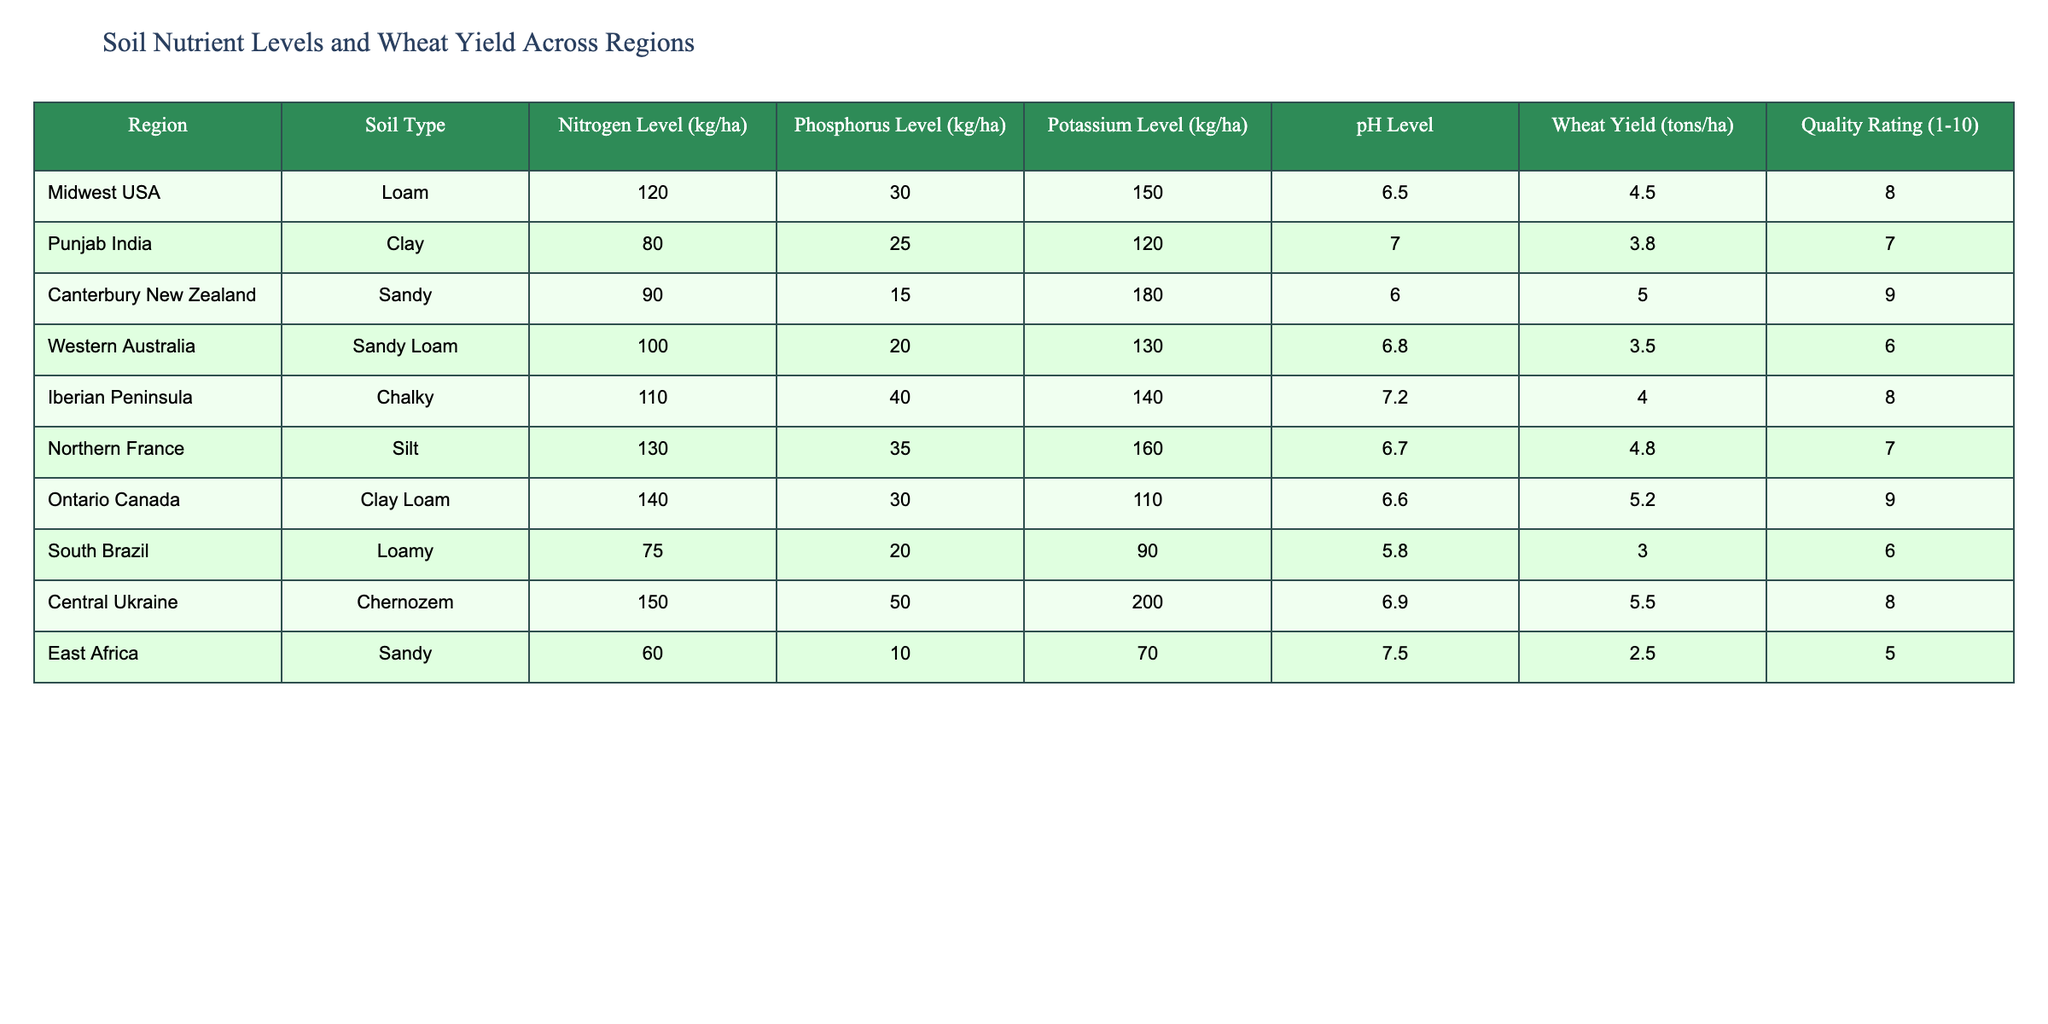What is the nitrogen level in Ontario Canada? In the table, locate the row corresponding to Ontario Canada. The nitrogen level for this region is specified in the Nitrogen Level column.
Answer: 140 kg/ha Which region has the highest wheat yield? To determine this, compare the Wheat Yield values across all regions. The highest value is identified in the Wheat Yield column corresponding to the region with the highest yield.
Answer: Central Ukraine, 5.5 tons/ha Is the soil in East Africa more acidic than in Punjab India? Assess the pH levels listed for East Africa and Punjab India. Comparing the two values will show if East Africa has a lower pH level, indicating higher acidity. East Africa has a pH of 7.5 while Punjab India has a pH of 7.0, therefore East Africa is not more acidic.
Answer: No What is the average phosphorus level across the listed regions? First, sum the Phosphorus Level values for each region: 30 + 25 + 15 + 20 + 40 + 35 + 30 + 20 + 50 + 10 =  275 kg/ha. Then, divide by the number of regions (10), yielding an average of 27.5 kg/ha.
Answer: 27.5 kg/ha Is there a direct correlation between nitrogen level and wheat yield in the table? To analyze this, we observe nitrogen levels and corresponding wheat yields. For example, as the nitrogen level increases in some regions, the wheat yield also tends to increase; however, there are exceptions. Therefore, while there might seem to be a pattern, it is not consistent across all regions.
Answer: No 